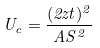<formula> <loc_0><loc_0><loc_500><loc_500>U _ { c } = \frac { ( 2 z t ) ^ { 2 } } { A S ^ { 2 } }</formula> 